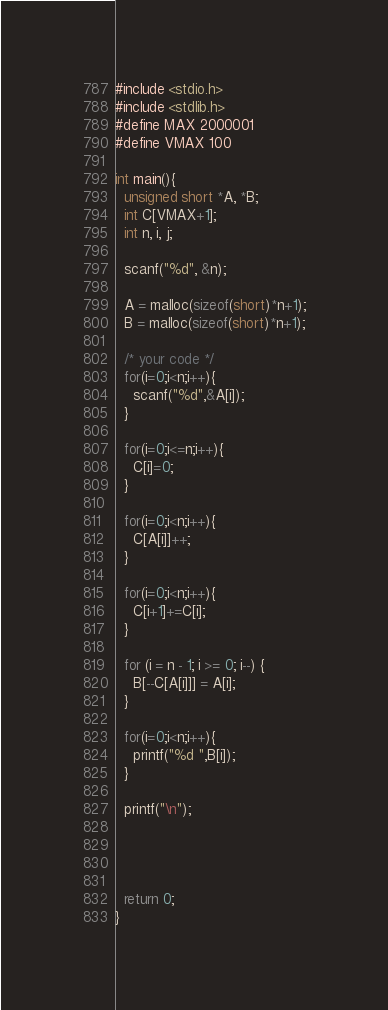Convert code to text. <code><loc_0><loc_0><loc_500><loc_500><_C_>#include <stdio.h>
#include <stdlib.h>
#define MAX 2000001
#define VMAX 100

int main(){
  unsigned short *A, *B;
  int C[VMAX+1];
  int n, i, j;

  scanf("%d", &n);

  A = malloc(sizeof(short)*n+1);
  B = malloc(sizeof(short)*n+1);

  /* your code */
  for(i=0;i<n;i++){
    scanf("%d",&A[i]);
  }

  for(i=0;i<=n;i++){
    C[i]=0;
  }

  for(i=0;i<n;i++){
    C[A[i]]++;
  }

  for(i=0;i<n;i++){
    C[i+1]+=C[i];
  }

  for (i = n - 1; i >= 0; i--) {
    B[--C[A[i]]] = A[i];
  }

  for(i=0;i<n;i++){
    printf("%d ",B[i]);
  }

  printf("\n");

  


  return 0;
}
</code> 